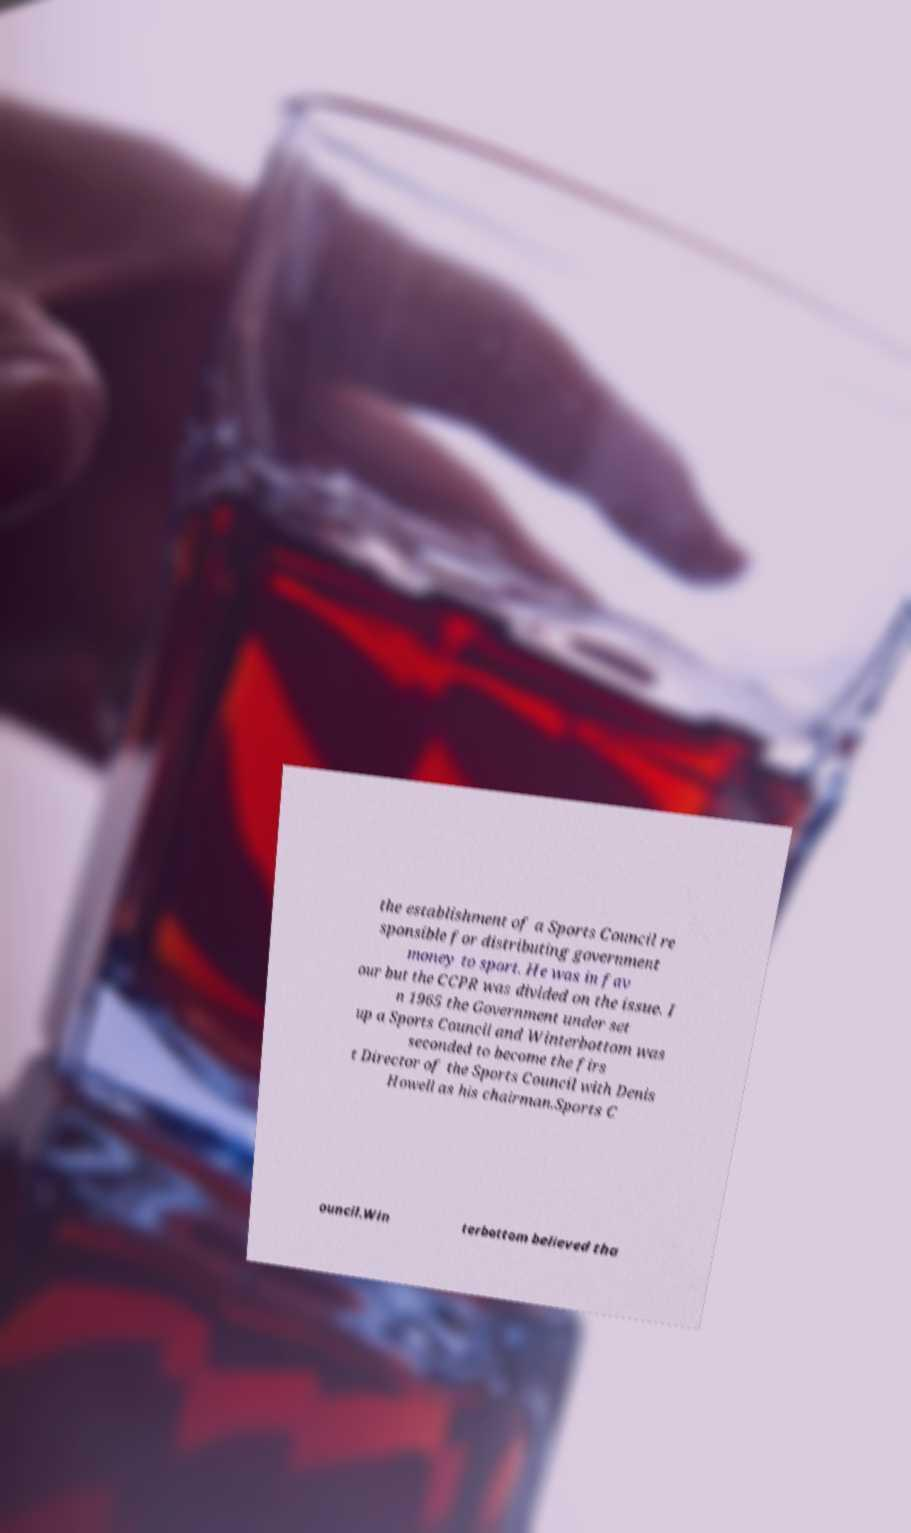Can you accurately transcribe the text from the provided image for me? the establishment of a Sports Council re sponsible for distributing government money to sport. He was in fav our but the CCPR was divided on the issue. I n 1965 the Government under set up a Sports Council and Winterbottom was seconded to become the firs t Director of the Sports Council with Denis Howell as his chairman.Sports C ouncil.Win terbottom believed tha 